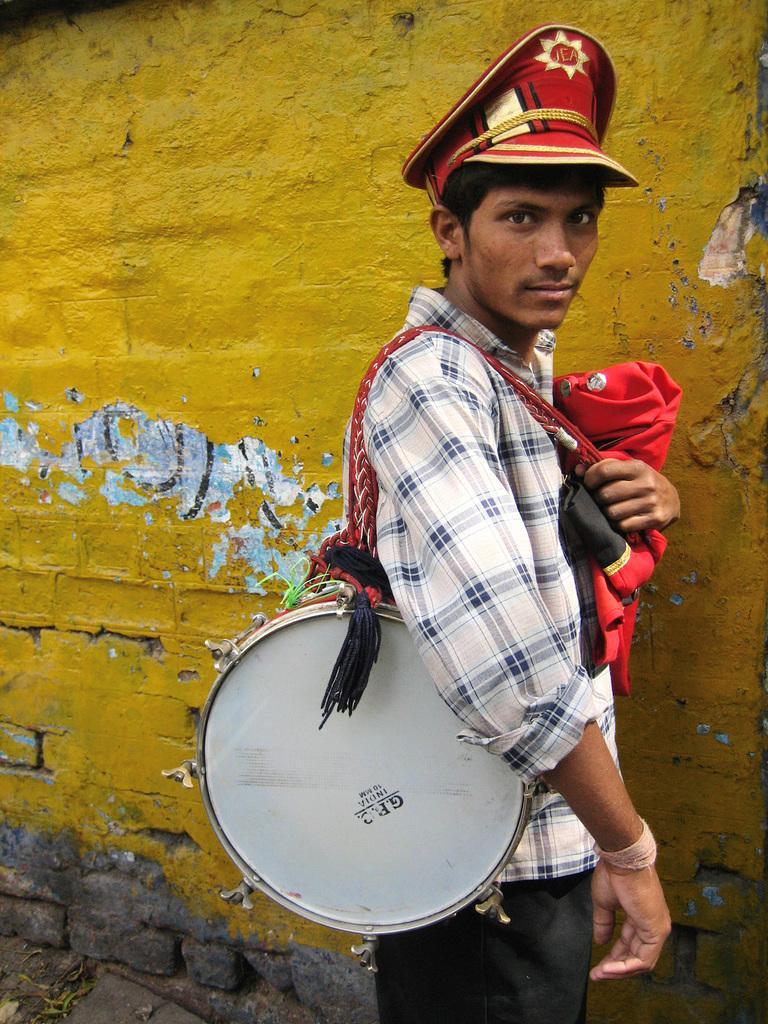Could you give a brief overview of what you see in this image? There is a man in the picture holding a drum on his shoulders. He's wearing a hat and holding a dress in his hand. In the background, there is a yellow colored wall. 